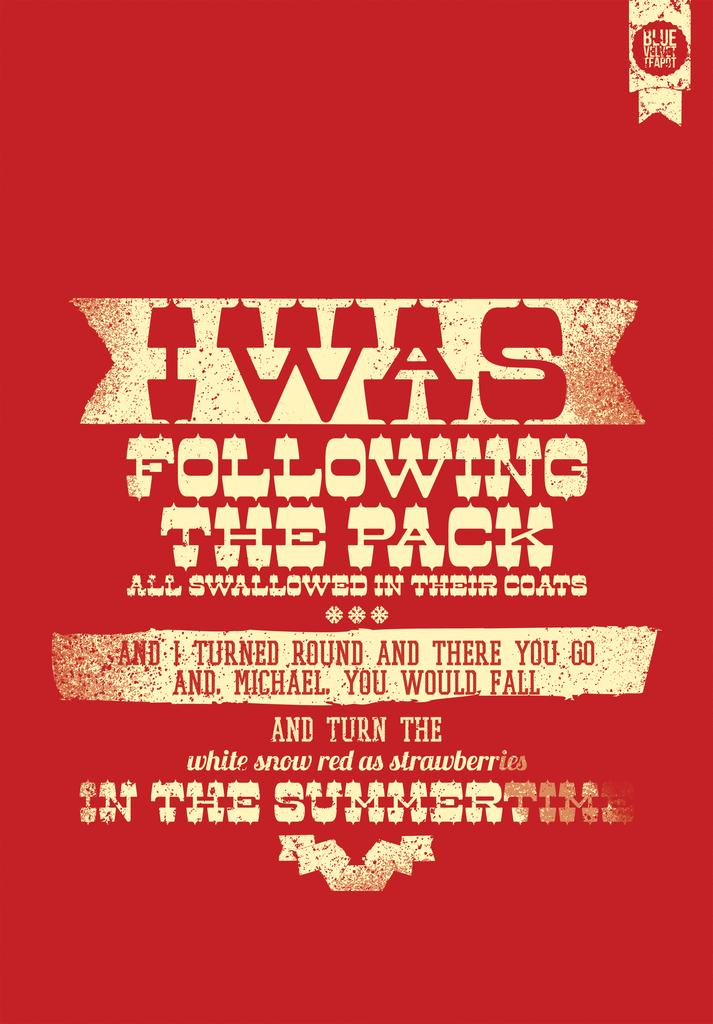<image>
Relay a brief, clear account of the picture shown. A red and white poster that says I was following the pack. 